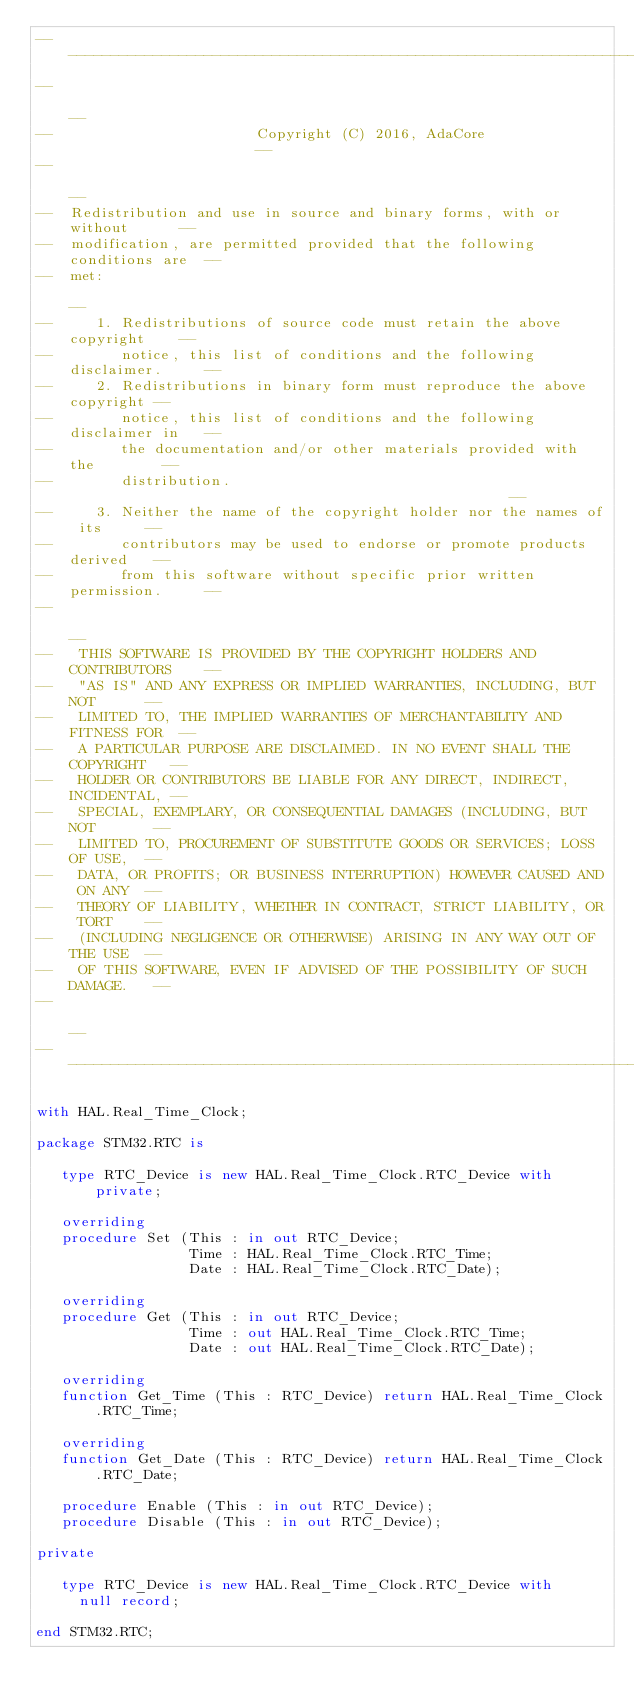<code> <loc_0><loc_0><loc_500><loc_500><_Ada_>------------------------------------------------------------------------------
--                                                                          --
--                        Copyright (C) 2016, AdaCore                       --
--                                                                          --
--  Redistribution and use in source and binary forms, with or without      --
--  modification, are permitted provided that the following conditions are  --
--  met:                                                                    --
--     1. Redistributions of source code must retain the above copyright    --
--        notice, this list of conditions and the following disclaimer.     --
--     2. Redistributions in binary form must reproduce the above copyright --
--        notice, this list of conditions and the following disclaimer in   --
--        the documentation and/or other materials provided with the        --
--        distribution.                                                     --
--     3. Neither the name of the copyright holder nor the names of its     --
--        contributors may be used to endorse or promote products derived   --
--        from this software without specific prior written permission.     --
--                                                                          --
--   THIS SOFTWARE IS PROVIDED BY THE COPYRIGHT HOLDERS AND CONTRIBUTORS    --
--   "AS IS" AND ANY EXPRESS OR IMPLIED WARRANTIES, INCLUDING, BUT NOT      --
--   LIMITED TO, THE IMPLIED WARRANTIES OF MERCHANTABILITY AND FITNESS FOR  --
--   A PARTICULAR PURPOSE ARE DISCLAIMED. IN NO EVENT SHALL THE COPYRIGHT   --
--   HOLDER OR CONTRIBUTORS BE LIABLE FOR ANY DIRECT, INDIRECT, INCIDENTAL, --
--   SPECIAL, EXEMPLARY, OR CONSEQUENTIAL DAMAGES (INCLUDING, BUT NOT       --
--   LIMITED TO, PROCUREMENT OF SUBSTITUTE GOODS OR SERVICES; LOSS OF USE,  --
--   DATA, OR PROFITS; OR BUSINESS INTERRUPTION) HOWEVER CAUSED AND ON ANY  --
--   THEORY OF LIABILITY, WHETHER IN CONTRACT, STRICT LIABILITY, OR TORT    --
--   (INCLUDING NEGLIGENCE OR OTHERWISE) ARISING IN ANY WAY OUT OF THE USE  --
--   OF THIS SOFTWARE, EVEN IF ADVISED OF THE POSSIBILITY OF SUCH DAMAGE.   --
--                                                                          --
------------------------------------------------------------------------------

with HAL.Real_Time_Clock;

package STM32.RTC is

   type RTC_Device is new HAL.Real_Time_Clock.RTC_Device with private;

   overriding
   procedure Set (This : in out RTC_Device;
                  Time : HAL.Real_Time_Clock.RTC_Time;
                  Date : HAL.Real_Time_Clock.RTC_Date);

   overriding
   procedure Get (This : in out RTC_Device;
                  Time : out HAL.Real_Time_Clock.RTC_Time;
                  Date : out HAL.Real_Time_Clock.RTC_Date);

   overriding
   function Get_Time (This : RTC_Device) return HAL.Real_Time_Clock.RTC_Time;

   overriding
   function Get_Date (This : RTC_Device) return HAL.Real_Time_Clock.RTC_Date;

   procedure Enable (This : in out RTC_Device);
   procedure Disable (This : in out RTC_Device);

private

   type RTC_Device is new HAL.Real_Time_Clock.RTC_Device with
     null record;

end STM32.RTC;
</code> 